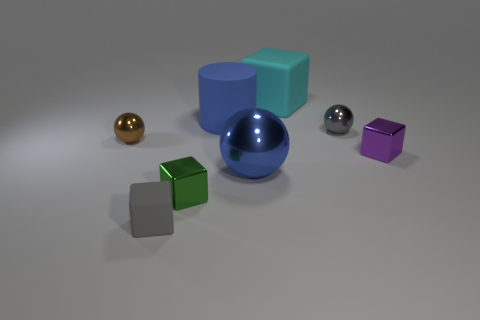Does the small matte thing have the same color as the big shiny ball?
Give a very brief answer. No. What number of things are either small metallic cubes that are behind the large metal sphere or tiny brown metal balls?
Offer a terse response. 2. Is the number of tiny metallic cubes behind the large cyan matte thing less than the number of big cyan matte things right of the gray shiny sphere?
Keep it short and to the point. No. How many other objects are there of the same size as the blue matte cylinder?
Your response must be concise. 2. Are the big blue cylinder and the small ball left of the small gray matte block made of the same material?
Your answer should be compact. No. How many things are either small blocks that are to the left of the green thing or large blue objects that are right of the gray matte object?
Offer a very short reply. 3. What color is the small matte block?
Your answer should be very brief. Gray. Is the number of tiny metal blocks that are to the left of the cyan block less than the number of brown metal spheres?
Make the answer very short. No. Is there anything else that is the same shape as the big metal object?
Ensure brevity in your answer.  Yes. Are any purple cylinders visible?
Provide a succinct answer. No. 